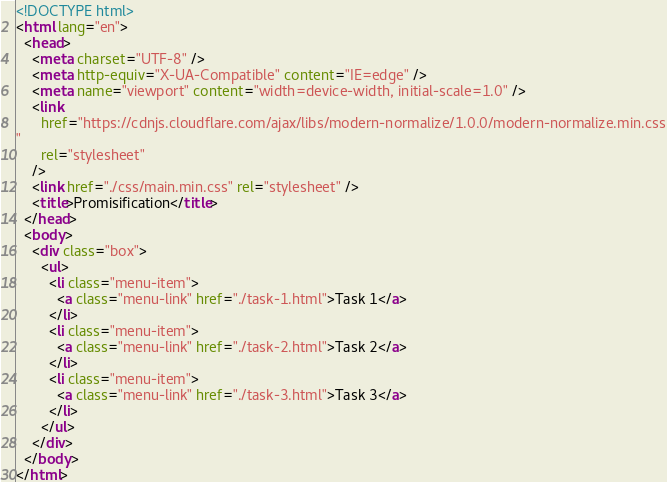<code> <loc_0><loc_0><loc_500><loc_500><_HTML_><!DOCTYPE html>
<html lang="en">
  <head>
    <meta charset="UTF-8" />
    <meta http-equiv="X-UA-Compatible" content="IE=edge" />
    <meta name="viewport" content="width=device-width, initial-scale=1.0" />
    <link
      href="https://cdnjs.cloudflare.com/ajax/libs/modern-normalize/1.0.0/modern-normalize.min.css
"
      rel="stylesheet"
    />
    <link href="./css/main.min.css" rel="stylesheet" />
    <title>Promisification</title>
  </head>
  <body>
    <div class="box">
      <ul>
        <li class="menu-item">
          <a class="menu-link" href="./task-1.html">Task 1</a>
        </li>
        <li class="menu-item">
          <a class="menu-link" href="./task-2.html">Task 2</a>
        </li>
        <li class="menu-item">
          <a class="menu-link" href="./task-3.html">Task 3</a>
        </li>
      </ul>
    </div>
  </body>
</html>
</code> 